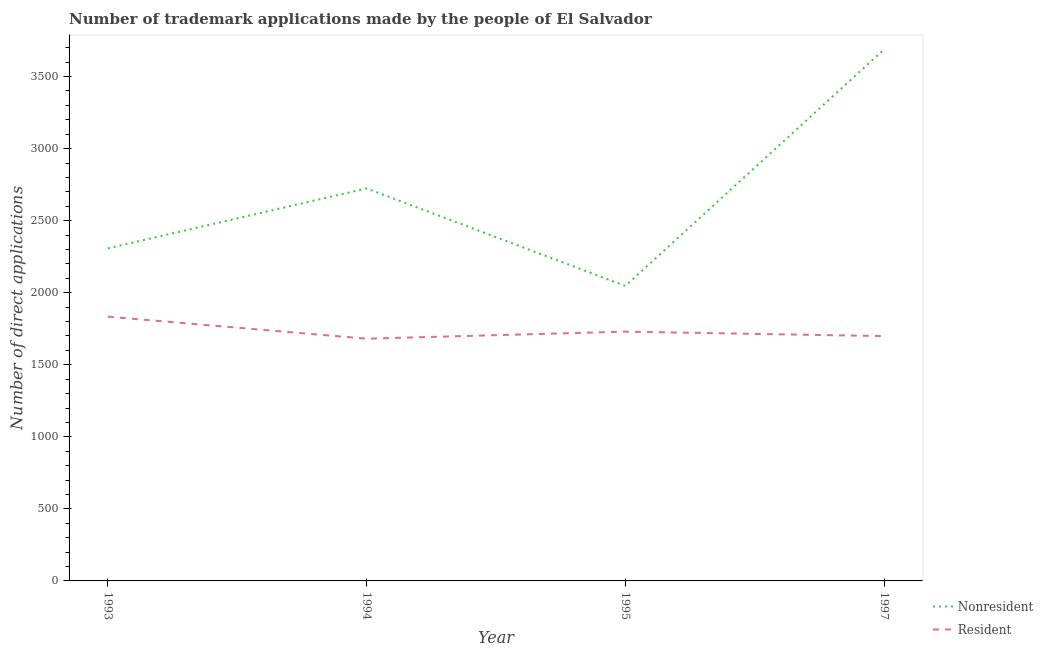How many different coloured lines are there?
Offer a very short reply. 2. Does the line corresponding to number of trademark applications made by non residents intersect with the line corresponding to number of trademark applications made by residents?
Offer a terse response. No. Is the number of lines equal to the number of legend labels?
Provide a short and direct response. Yes. What is the number of trademark applications made by residents in 1995?
Make the answer very short. 1730. Across all years, what is the maximum number of trademark applications made by residents?
Provide a short and direct response. 1834. Across all years, what is the minimum number of trademark applications made by residents?
Offer a terse response. 1681. In which year was the number of trademark applications made by non residents maximum?
Your response must be concise. 1997. What is the total number of trademark applications made by non residents in the graph?
Offer a terse response. 1.08e+04. What is the difference between the number of trademark applications made by non residents in 1994 and that in 1995?
Your response must be concise. 677. What is the difference between the number of trademark applications made by residents in 1997 and the number of trademark applications made by non residents in 1994?
Your answer should be very brief. -1025. What is the average number of trademark applications made by non residents per year?
Your response must be concise. 2692. In the year 1997, what is the difference between the number of trademark applications made by residents and number of trademark applications made by non residents?
Make the answer very short. -1990. What is the ratio of the number of trademark applications made by non residents in 1993 to that in 1995?
Ensure brevity in your answer.  1.13. What is the difference between the highest and the second highest number of trademark applications made by residents?
Your answer should be very brief. 104. What is the difference between the highest and the lowest number of trademark applications made by residents?
Your answer should be very brief. 153. In how many years, is the number of trademark applications made by residents greater than the average number of trademark applications made by residents taken over all years?
Your response must be concise. 1. Is the sum of the number of trademark applications made by non residents in 1995 and 1997 greater than the maximum number of trademark applications made by residents across all years?
Provide a short and direct response. Yes. Does the number of trademark applications made by residents monotonically increase over the years?
Your response must be concise. No. Is the number of trademark applications made by non residents strictly greater than the number of trademark applications made by residents over the years?
Your answer should be compact. Yes. How many years are there in the graph?
Provide a short and direct response. 4. What is the difference between two consecutive major ticks on the Y-axis?
Provide a succinct answer. 500. Are the values on the major ticks of Y-axis written in scientific E-notation?
Your answer should be very brief. No. Does the graph contain any zero values?
Your answer should be compact. No. Does the graph contain grids?
Provide a short and direct response. No. Where does the legend appear in the graph?
Provide a short and direct response. Bottom right. How many legend labels are there?
Provide a succinct answer. 2. How are the legend labels stacked?
Your answer should be compact. Vertical. What is the title of the graph?
Your answer should be compact. Number of trademark applications made by the people of El Salvador. What is the label or title of the X-axis?
Ensure brevity in your answer.  Year. What is the label or title of the Y-axis?
Your answer should be compact. Number of direct applications. What is the Number of direct applications of Nonresident in 1993?
Keep it short and to the point. 2308. What is the Number of direct applications of Resident in 1993?
Ensure brevity in your answer.  1834. What is the Number of direct applications of Nonresident in 1994?
Make the answer very short. 2724. What is the Number of direct applications of Resident in 1994?
Your answer should be very brief. 1681. What is the Number of direct applications in Nonresident in 1995?
Provide a short and direct response. 2047. What is the Number of direct applications in Resident in 1995?
Make the answer very short. 1730. What is the Number of direct applications of Nonresident in 1997?
Your answer should be compact. 3689. What is the Number of direct applications in Resident in 1997?
Your response must be concise. 1699. Across all years, what is the maximum Number of direct applications in Nonresident?
Ensure brevity in your answer.  3689. Across all years, what is the maximum Number of direct applications of Resident?
Ensure brevity in your answer.  1834. Across all years, what is the minimum Number of direct applications in Nonresident?
Make the answer very short. 2047. Across all years, what is the minimum Number of direct applications in Resident?
Provide a succinct answer. 1681. What is the total Number of direct applications in Nonresident in the graph?
Offer a terse response. 1.08e+04. What is the total Number of direct applications in Resident in the graph?
Your answer should be very brief. 6944. What is the difference between the Number of direct applications of Nonresident in 1993 and that in 1994?
Your answer should be compact. -416. What is the difference between the Number of direct applications in Resident in 1993 and that in 1994?
Provide a succinct answer. 153. What is the difference between the Number of direct applications in Nonresident in 1993 and that in 1995?
Your response must be concise. 261. What is the difference between the Number of direct applications in Resident in 1993 and that in 1995?
Your response must be concise. 104. What is the difference between the Number of direct applications of Nonresident in 1993 and that in 1997?
Provide a short and direct response. -1381. What is the difference between the Number of direct applications in Resident in 1993 and that in 1997?
Your answer should be compact. 135. What is the difference between the Number of direct applications in Nonresident in 1994 and that in 1995?
Keep it short and to the point. 677. What is the difference between the Number of direct applications in Resident in 1994 and that in 1995?
Keep it short and to the point. -49. What is the difference between the Number of direct applications in Nonresident in 1994 and that in 1997?
Ensure brevity in your answer.  -965. What is the difference between the Number of direct applications in Resident in 1994 and that in 1997?
Ensure brevity in your answer.  -18. What is the difference between the Number of direct applications in Nonresident in 1995 and that in 1997?
Offer a very short reply. -1642. What is the difference between the Number of direct applications of Resident in 1995 and that in 1997?
Ensure brevity in your answer.  31. What is the difference between the Number of direct applications of Nonresident in 1993 and the Number of direct applications of Resident in 1994?
Give a very brief answer. 627. What is the difference between the Number of direct applications of Nonresident in 1993 and the Number of direct applications of Resident in 1995?
Keep it short and to the point. 578. What is the difference between the Number of direct applications of Nonresident in 1993 and the Number of direct applications of Resident in 1997?
Your response must be concise. 609. What is the difference between the Number of direct applications of Nonresident in 1994 and the Number of direct applications of Resident in 1995?
Your response must be concise. 994. What is the difference between the Number of direct applications in Nonresident in 1994 and the Number of direct applications in Resident in 1997?
Your answer should be compact. 1025. What is the difference between the Number of direct applications of Nonresident in 1995 and the Number of direct applications of Resident in 1997?
Your answer should be very brief. 348. What is the average Number of direct applications of Nonresident per year?
Your response must be concise. 2692. What is the average Number of direct applications of Resident per year?
Your response must be concise. 1736. In the year 1993, what is the difference between the Number of direct applications in Nonresident and Number of direct applications in Resident?
Your answer should be very brief. 474. In the year 1994, what is the difference between the Number of direct applications in Nonresident and Number of direct applications in Resident?
Your response must be concise. 1043. In the year 1995, what is the difference between the Number of direct applications in Nonresident and Number of direct applications in Resident?
Your response must be concise. 317. In the year 1997, what is the difference between the Number of direct applications of Nonresident and Number of direct applications of Resident?
Offer a terse response. 1990. What is the ratio of the Number of direct applications in Nonresident in 1993 to that in 1994?
Ensure brevity in your answer.  0.85. What is the ratio of the Number of direct applications in Resident in 1993 to that in 1994?
Keep it short and to the point. 1.09. What is the ratio of the Number of direct applications of Nonresident in 1993 to that in 1995?
Provide a succinct answer. 1.13. What is the ratio of the Number of direct applications in Resident in 1993 to that in 1995?
Your answer should be compact. 1.06. What is the ratio of the Number of direct applications in Nonresident in 1993 to that in 1997?
Your response must be concise. 0.63. What is the ratio of the Number of direct applications in Resident in 1993 to that in 1997?
Provide a short and direct response. 1.08. What is the ratio of the Number of direct applications in Nonresident in 1994 to that in 1995?
Offer a very short reply. 1.33. What is the ratio of the Number of direct applications in Resident in 1994 to that in 1995?
Your response must be concise. 0.97. What is the ratio of the Number of direct applications in Nonresident in 1994 to that in 1997?
Ensure brevity in your answer.  0.74. What is the ratio of the Number of direct applications in Nonresident in 1995 to that in 1997?
Provide a succinct answer. 0.55. What is the ratio of the Number of direct applications in Resident in 1995 to that in 1997?
Your answer should be very brief. 1.02. What is the difference between the highest and the second highest Number of direct applications in Nonresident?
Your answer should be compact. 965. What is the difference between the highest and the second highest Number of direct applications of Resident?
Your answer should be very brief. 104. What is the difference between the highest and the lowest Number of direct applications in Nonresident?
Offer a terse response. 1642. What is the difference between the highest and the lowest Number of direct applications of Resident?
Your answer should be very brief. 153. 